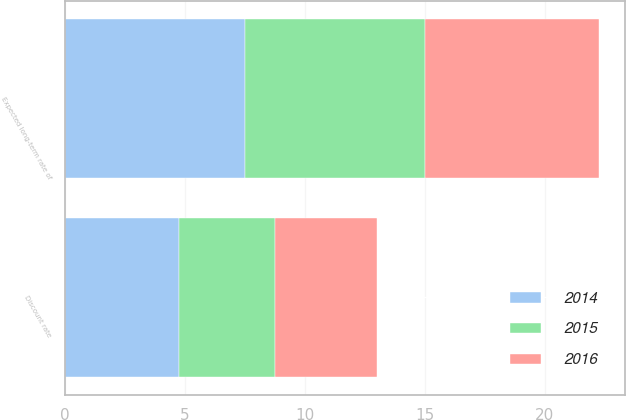Convert chart. <chart><loc_0><loc_0><loc_500><loc_500><stacked_bar_chart><ecel><fcel>Discount rate<fcel>Expected long-term rate of<nl><fcel>2016<fcel>4.27<fcel>7.25<nl><fcel>2015<fcel>4<fcel>7.5<nl><fcel>2014<fcel>4.75<fcel>7.5<nl></chart> 